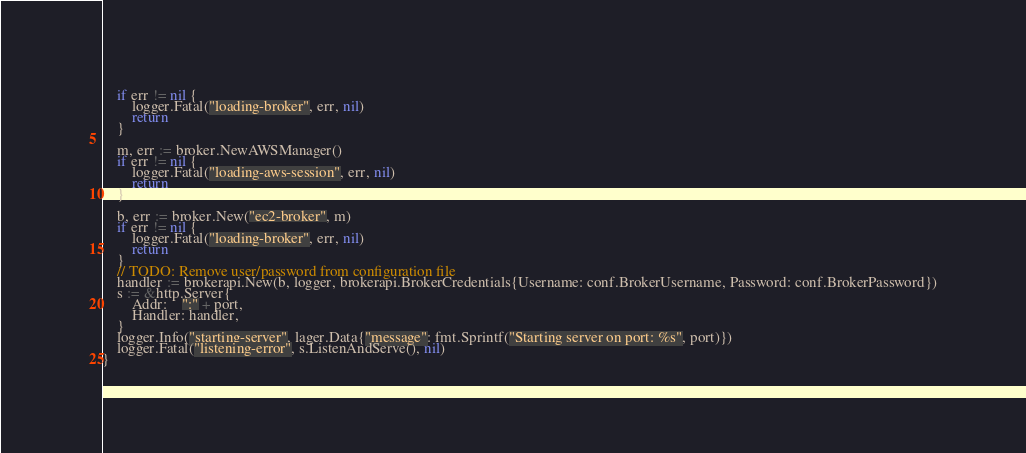Convert code to text. <code><loc_0><loc_0><loc_500><loc_500><_Go_>	if err != nil {
		logger.Fatal("loading-broker", err, nil)
		return
	}

	m, err := broker.NewAWSManager()
	if err != nil {
		logger.Fatal("loading-aws-session", err, nil)
		return
	}

	b, err := broker.New("ec2-broker", m)
	if err != nil {
		logger.Fatal("loading-broker", err, nil)
		return
	}
	// TODO: Remove user/password from configuration file
	handler := brokerapi.New(b, logger, brokerapi.BrokerCredentials{Username: conf.BrokerUsername, Password: conf.BrokerPassword})
	s := &http.Server{
		Addr:    ":" + port,
		Handler: handler,
	}
	logger.Info("starting-server", lager.Data{"message": fmt.Sprintf("Starting server on port: %s", port)})
	logger.Fatal("listening-error", s.ListenAndServe(), nil)
}
</code> 